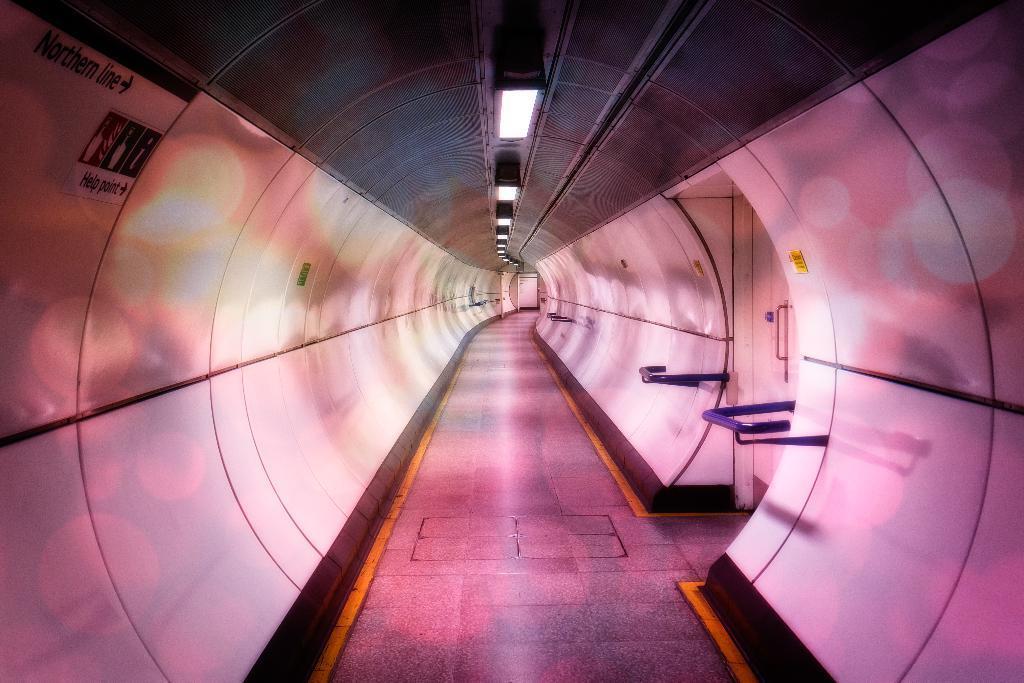Describe this image in one or two sentences. In the given image i can see a tunnel. 